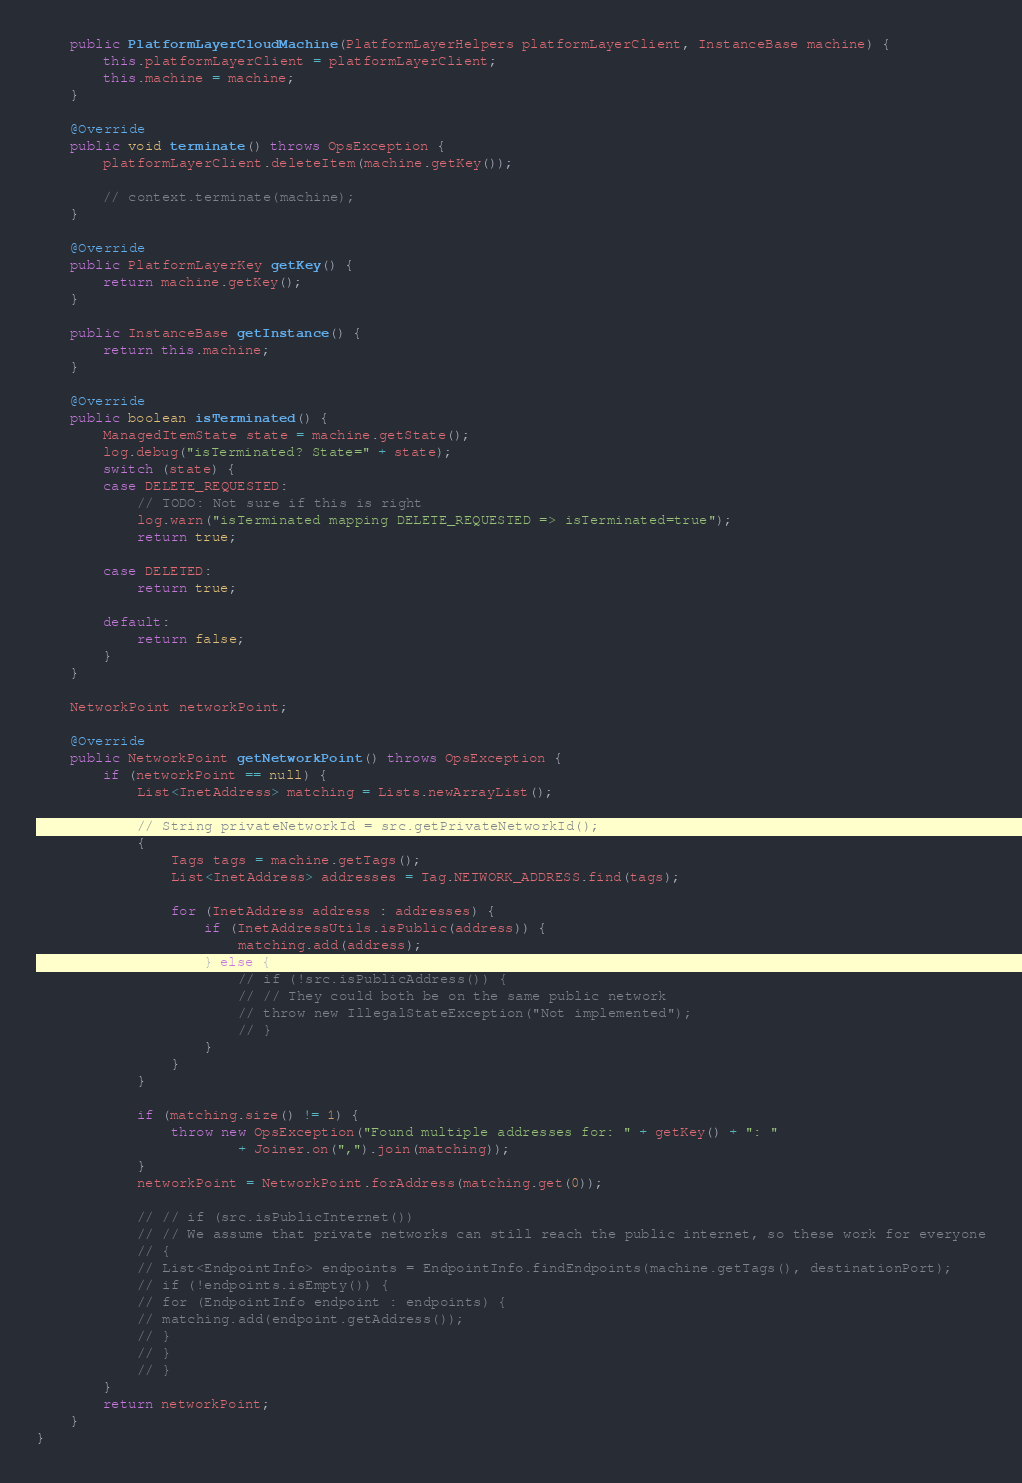Convert code to text. <code><loc_0><loc_0><loc_500><loc_500><_Java_>
	public PlatformLayerCloudMachine(PlatformLayerHelpers platformLayerClient, InstanceBase machine) {
		this.platformLayerClient = platformLayerClient;
		this.machine = machine;
	}

	@Override
	public void terminate() throws OpsException {
		platformLayerClient.deleteItem(machine.getKey());

		// context.terminate(machine);
	}

	@Override
	public PlatformLayerKey getKey() {
		return machine.getKey();
	}

	public InstanceBase getInstance() {
		return this.machine;
	}

	@Override
	public boolean isTerminated() {
		ManagedItemState state = machine.getState();
		log.debug("isTerminated? State=" + state);
		switch (state) {
		case DELETE_REQUESTED:
			// TODO: Not sure if this is right
			log.warn("isTerminated mapping DELETE_REQUESTED => isTerminated=true");
			return true;

		case DELETED:
			return true;

		default:
			return false;
		}
	}

	NetworkPoint networkPoint;

	@Override
	public NetworkPoint getNetworkPoint() throws OpsException {
		if (networkPoint == null) {
			List<InetAddress> matching = Lists.newArrayList();

			// String privateNetworkId = src.getPrivateNetworkId();
			{
				Tags tags = machine.getTags();
				List<InetAddress> addresses = Tag.NETWORK_ADDRESS.find(tags);

				for (InetAddress address : addresses) {
					if (InetAddressUtils.isPublic(address)) {
						matching.add(address);
					} else {
						// if (!src.isPublicAddress()) {
						// // They could both be on the same public network
						// throw new IllegalStateException("Not implemented");
						// }
					}
				}
			}

			if (matching.size() != 1) {
				throw new OpsException("Found multiple addresses for: " + getKey() + ": "
						+ Joiner.on(",").join(matching));
			}
			networkPoint = NetworkPoint.forAddress(matching.get(0));

			// // if (src.isPublicInternet())
			// // We assume that private networks can still reach the public internet, so these work for everyone
			// {
			// List<EndpointInfo> endpoints = EndpointInfo.findEndpoints(machine.getTags(), destinationPort);
			// if (!endpoints.isEmpty()) {
			// for (EndpointInfo endpoint : endpoints) {
			// matching.add(endpoint.getAddress());
			// }
			// }
			// }
		}
		return networkPoint;
	}
}
</code> 